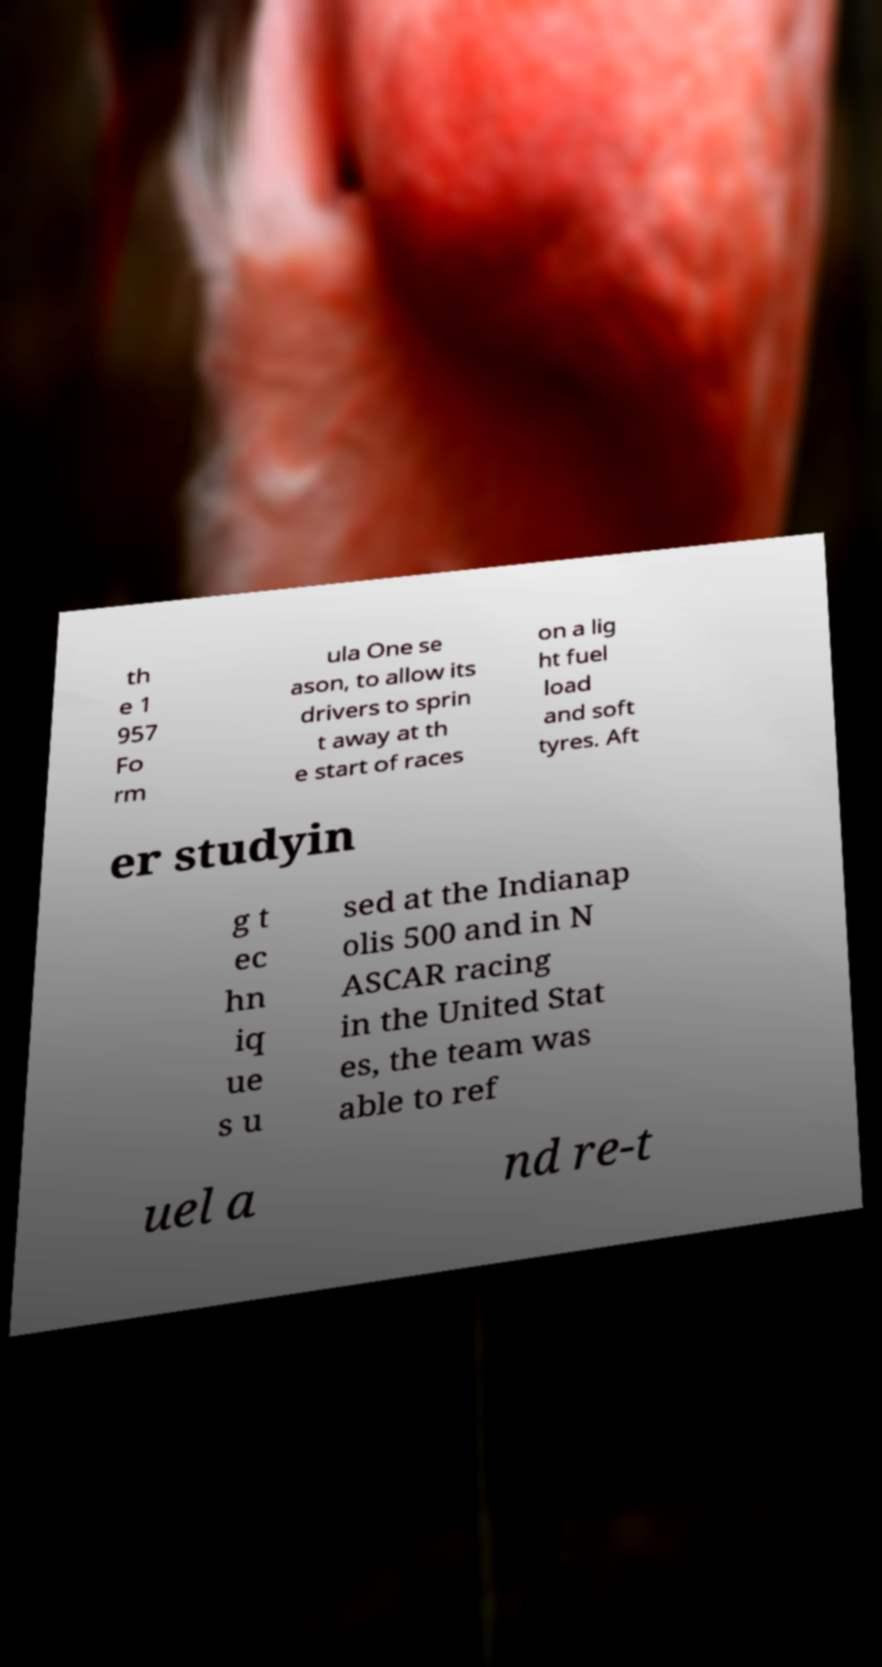Can you read and provide the text displayed in the image?This photo seems to have some interesting text. Can you extract and type it out for me? th e 1 957 Fo rm ula One se ason, to allow its drivers to sprin t away at th e start of races on a lig ht fuel load and soft tyres. Aft er studyin g t ec hn iq ue s u sed at the Indianap olis 500 and in N ASCAR racing in the United Stat es, the team was able to ref uel a nd re-t 